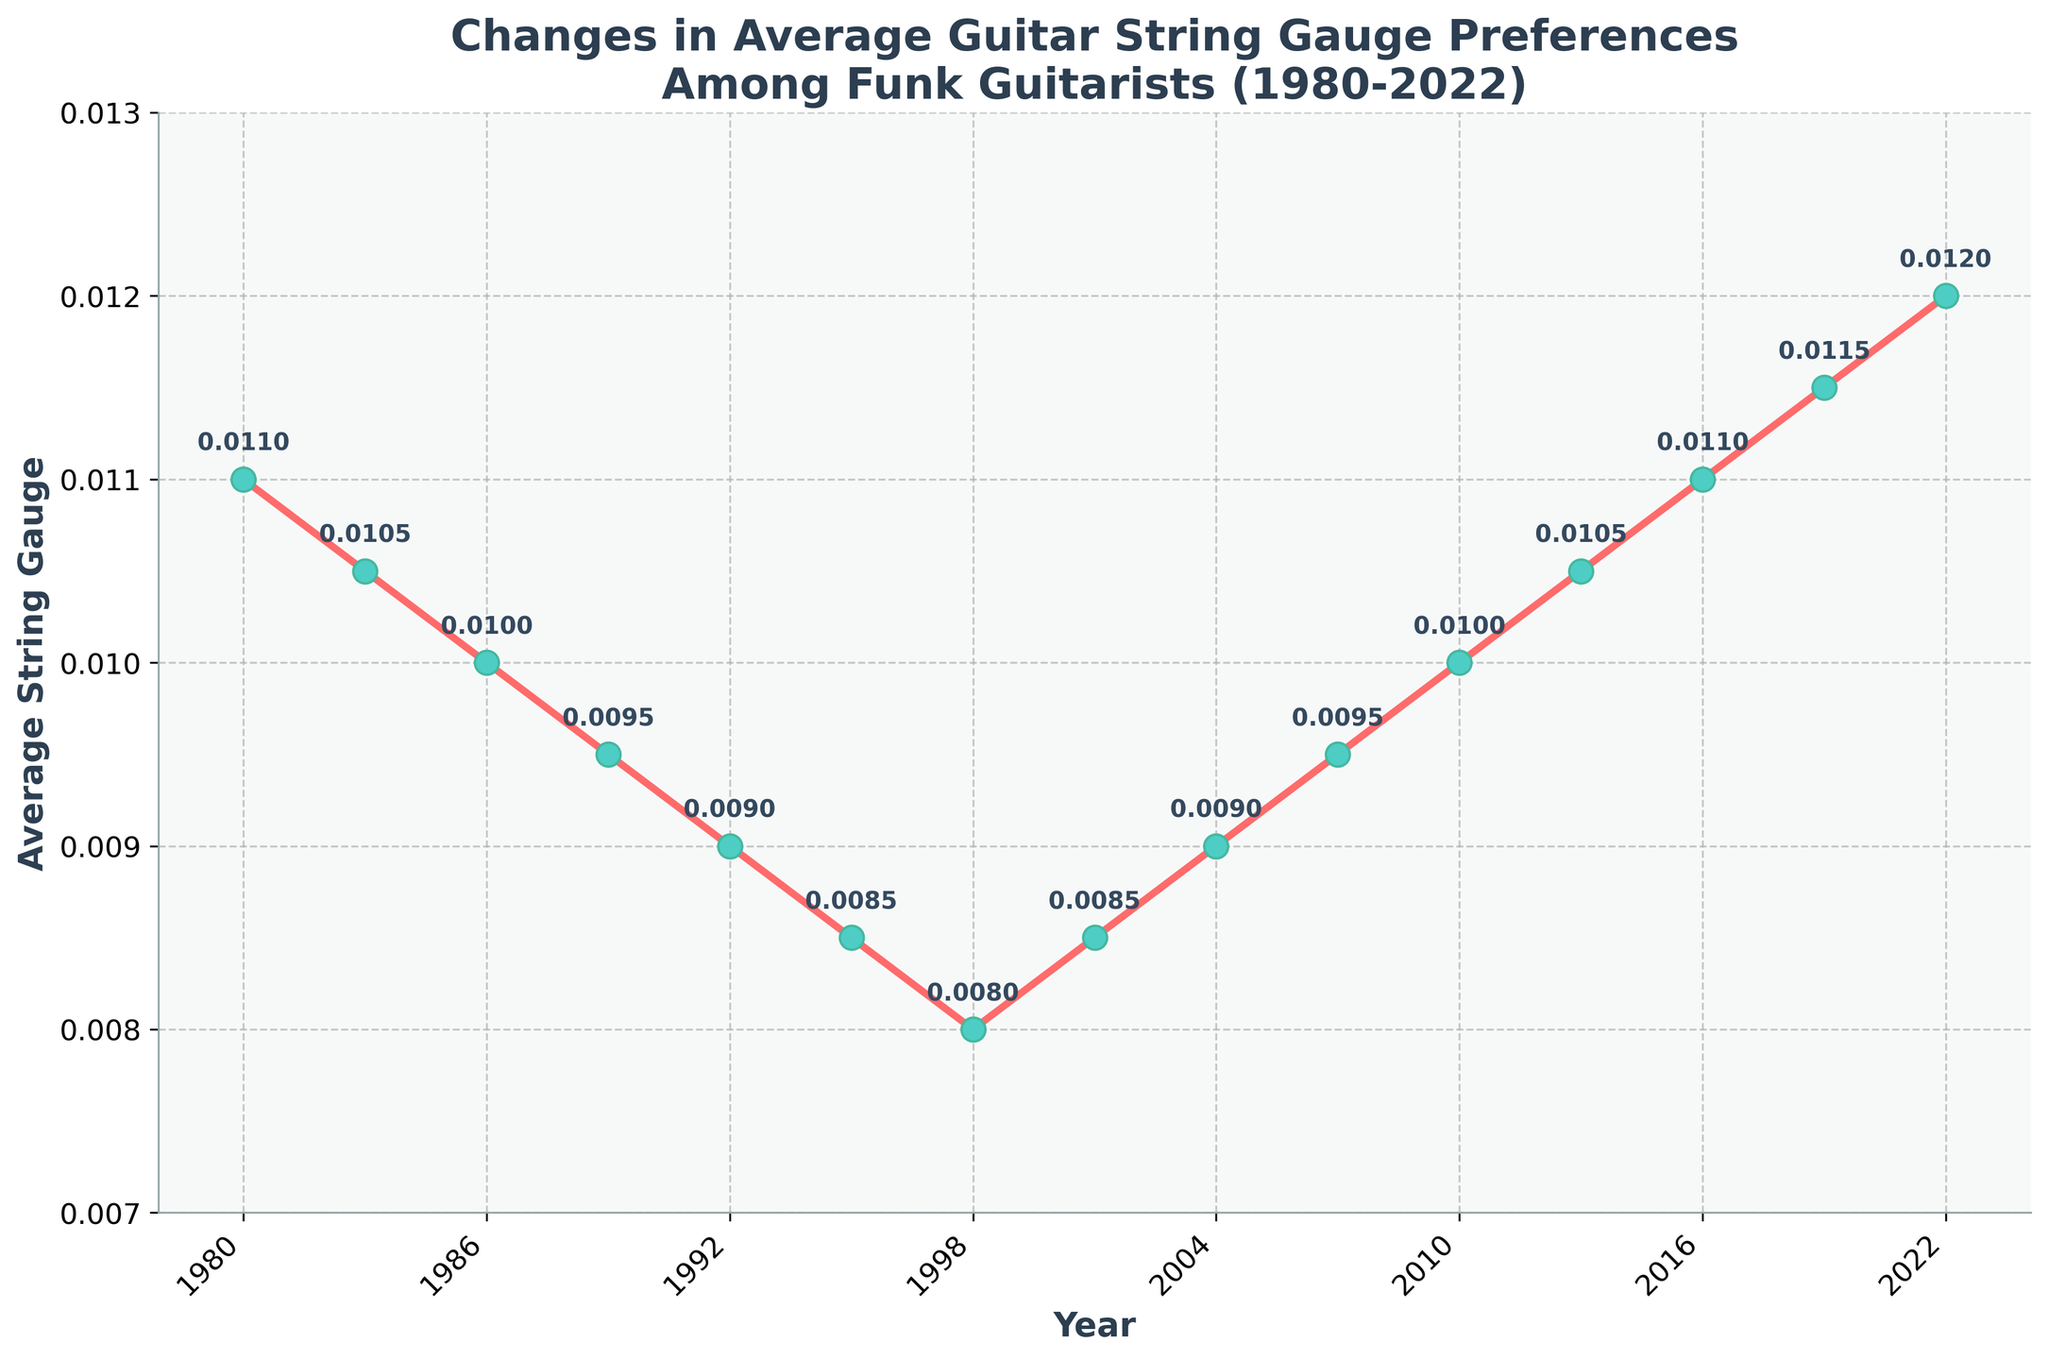What is the trend in average guitar string gauge preferences among funk guitarists from 1980 to 2022? The graph shows a clear downward trend in average guitar string gauge preferences from 1980 (0.011) to 1998 (0.008). After 1998, it shows an initial upward trend from 2001 (0.0085) to 2010 (0.010) followed by a continued upward trend peaking at 2022 (0.012). Thus, overall, there's a decreasing trend followed by an increasing trend.
Answer: Decreasing, then increasing During which period did the average string gauge preference show the most significant decline? By examining the data points on the graph, the period between 1980 (0.011) and 1998 (0.008) shows a continuous decline, the most significant drop being between 1980 and 1995. The gauge drops from 0.011 in 1980 to 0.0085 in 1995.
Answer: 1980 to 1995 In which year did the average string gauge preference first rise after hitting its lowest point? The graph indicates that the lowest point is in 1998 (0.008). Subsequently, the average string gauge preference rises in the year 2001 to 0.0085.
Answer: 2001 What is the difference in the average string gauge between 1980 and 2022? In 1980, the average string gauge was 0.011 and in 2022 it was 0.012. The difference is obtained by subtracting the 1980 value from the 2022 value: 0.012 - 0.011 = 0.001.
Answer: 0.001 Which year marks the highest average guitar string gauge among the data points provided? The graph shows that the highest average guitar string gauge is in 2022, with a value of 0.012.
Answer: 2022 How did the average string gauge change from 2010 to 2016? From the graph, the average string gauge in 2010 was 0.010. It increased to 0.011 in 2016. Therefore, the change is an increase of 0.001 units.
Answer: Increased by 0.001 Was there any period where the average guitar string gauge remained constant? If yes, specify the period. The graph shows that from 1998 to 2001, the average guitar string gauge remained constant at 0.008.
Answer: 1998 to 2001 Compare the average string gauge preference in 1983 and 1989. In 1983, the average string gauge preference was 0.0105 and in 1989 it was 0.0095. Thus, the gauge preference decreased by 0.001 units from 1983 to 1989.
Answer: It decreased by 0.001 What is the average value of the string gauge preferences in the years 2001, 2004, and 2007? The string gauge values for the years 2001, 2004, and 2007 are 0.0085, 0.009, and 0.0095 respectively. To find the average: \((0.0085 + 0.009 + 0.0095) / 3 = 0.009\).
Answer: 0.009 